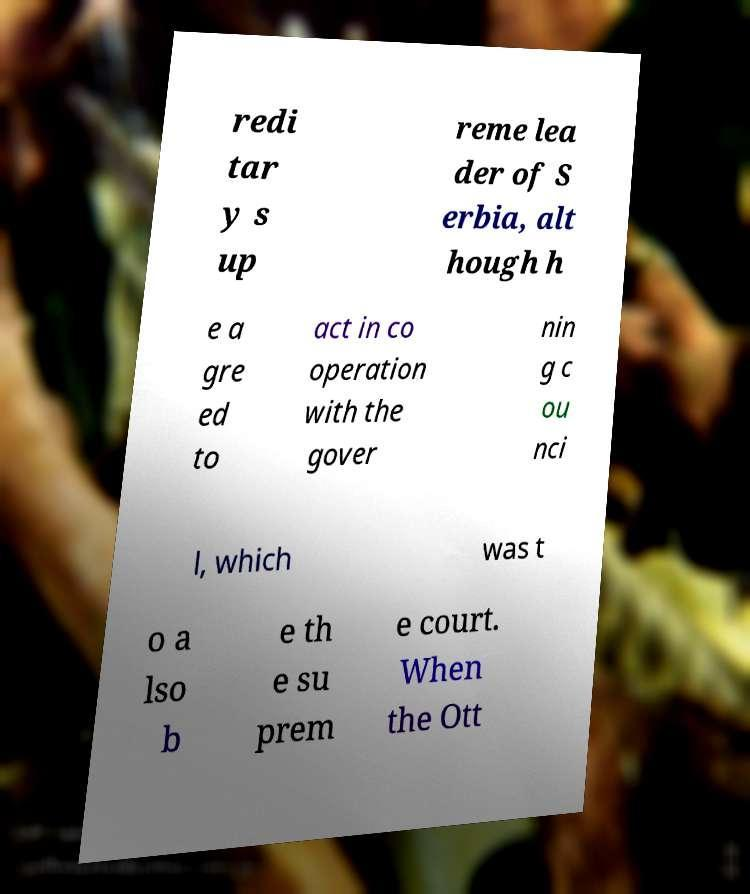Could you extract and type out the text from this image? redi tar y s up reme lea der of S erbia, alt hough h e a gre ed to act in co operation with the gover nin g c ou nci l, which was t o a lso b e th e su prem e court. When the Ott 